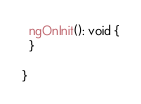<code> <loc_0><loc_0><loc_500><loc_500><_TypeScript_>
  ngOnInit(): void {
  }

}
</code> 